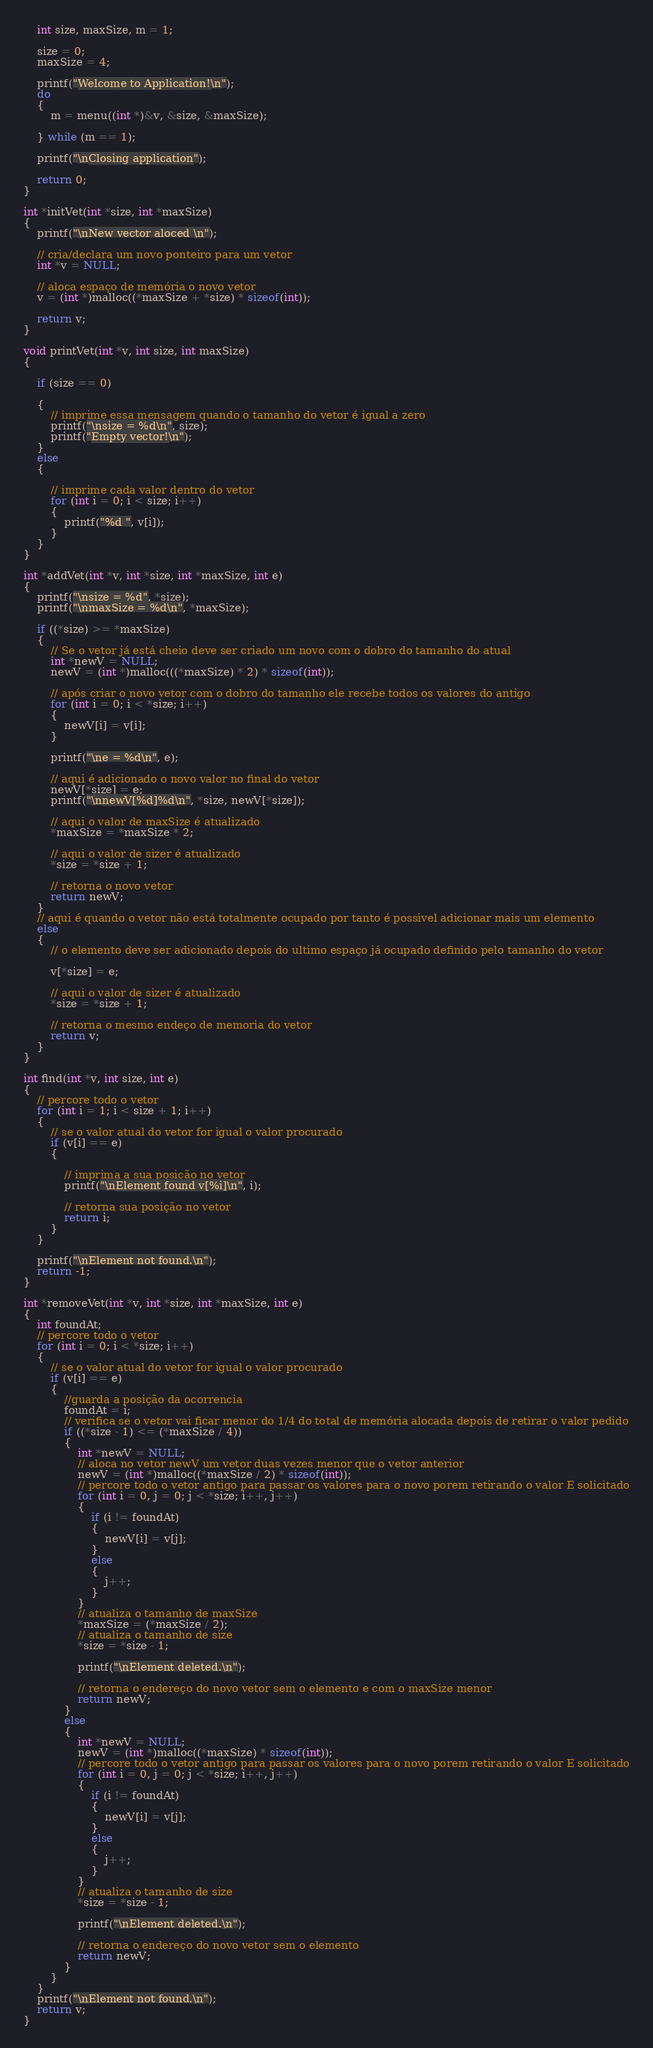<code> <loc_0><loc_0><loc_500><loc_500><_C_>    int size, maxSize, m = 1;

    size = 0;
    maxSize = 4;

    printf("Welcome to Application!\n");
    do
    {
        m = menu((int *)&v, &size, &maxSize);

    } while (m == 1);

    printf("\nClosing application");

    return 0;
}

int *initVet(int *size, int *maxSize)
{
    printf("\nNew vector aloced \n");

    // cria/declara um novo ponteiro para um vetor
    int *v = NULL;

    // aloca espaço de memória o novo vetor
    v = (int *)malloc((*maxSize + *size) * sizeof(int));

    return v;
}

void printVet(int *v, int size, int maxSize)
{

    if (size == 0)

    {
        // imprime essa mensagem quando o tamanho do vetor é igual a zero
        printf("\nsize = %d\n", size);
        printf("Empty vector!\n");
    }
    else
    {

        // imprime cada valor dentro do vetor
        for (int i = 0; i < size; i++)
        {
            printf("%d ", v[i]);
        }
    }
}

int *addVet(int *v, int *size, int *maxSize, int e)
{
    printf("\nsize = %d", *size);
    printf("\nmaxSize = %d\n", *maxSize);

    if ((*size) >= *maxSize)
    {
        // Se o vetor já está cheio deve ser criado um novo com o dobro do tamanho do atual
        int *newV = NULL;
        newV = (int *)malloc(((*maxSize) * 2) * sizeof(int));

        // após criar o novo vetor com o dobro do tamanho ele recebe todos os valores do antigo
        for (int i = 0; i < *size; i++)
        {
            newV[i] = v[i];
        }

        printf("\ne = %d\n", e);

        // aqui é adicionado o novo valor no final do vetor
        newV[*size] = e;
        printf("\nnewV[%d]%d\n", *size, newV[*size]);

        // aqui o valor de maxSize é atualizado
        *maxSize = *maxSize * 2;

        // aqui o valor de sizer é atualizado
        *size = *size + 1;

        // retorna o novo vetor
        return newV;
    }
    // aqui é quando o vetor não está totalmente ocupado por tanto é possivel adicionar mais um elemento
    else
    {
        // o elemento deve ser adicionado depois do ultimo espaço já ocupado definido pelo tamanho do vetor

        v[*size] = e;

        // aqui o valor de sizer é atualizado
        *size = *size + 1;

        // retorna o mesmo endeço de memoria do vetor
        return v;
    }
}

int find(int *v, int size, int e)
{
    // percore todo o vetor
    for (int i = 1; i < size + 1; i++)
    {
        // se o valor atual do vetor for igual o valor procurado
        if (v[i] == e)
        {

            // imprima a sua posição no vetor
            printf("\nElement found v[%i]\n", i);

            // retorna sua posição no vetor
            return i;
        }
    }

    printf("\nElement not found.\n");
    return -1;
}

int *removeVet(int *v, int *size, int *maxSize, int e)
{
    int foundAt;
    // percore todo o vetor
    for (int i = 0; i < *size; i++)
    {
        // se o valor atual do vetor for igual o valor procurado
        if (v[i] == e)
        {
            //guarda a posição da ocorrencia
            foundAt = i;
            // verifica se o vetor vai ficar menor do 1/4 do total de memória alocada depois de retirar o valor pedido
            if ((*size - 1) <= (*maxSize / 4))
            {
                int *newV = NULL;
                // aloca no vetor newV um vetor duas vezes menor que o vetor anterior
                newV = (int *)malloc((*maxSize / 2) * sizeof(int));
                // percore todo o vetor antigo para passar os valores para o novo porem retirando o valor E solicitado
                for (int i = 0, j = 0; j < *size; i++, j++)
                {
                    if (i != foundAt)
                    {
                        newV[i] = v[j];
                    }
                    else
                    {
                        j++;
                    }
                }
                // atualiza o tamanho de maxSize
                *maxSize = (*maxSize / 2);
                // atualiza o tamanho de size
                *size = *size - 1;

                printf("\nElement deleted.\n");

                // retorna o endereço do novo vetor sem o elemento e com o maxSize menor
                return newV;
            }
            else
            {
                int *newV = NULL;
                newV = (int *)malloc((*maxSize) * sizeof(int));
                // percore todo o vetor antigo para passar os valores para o novo porem retirando o valor E solicitado
                for (int i = 0, j = 0; j < *size; i++, j++)
                {
                    if (i != foundAt)
                    {
                        newV[i] = v[j];
                    }
                    else
                    {
                        j++;
                    }
                }
                // atualiza o tamanho de size
                *size = *size - 1;

                printf("\nElement deleted.\n");

                // retorna o endereço do novo vetor sem o elemento
                return newV;
            }
        }
    }
    printf("\nElement not found.\n");
    return v;
}</code> 